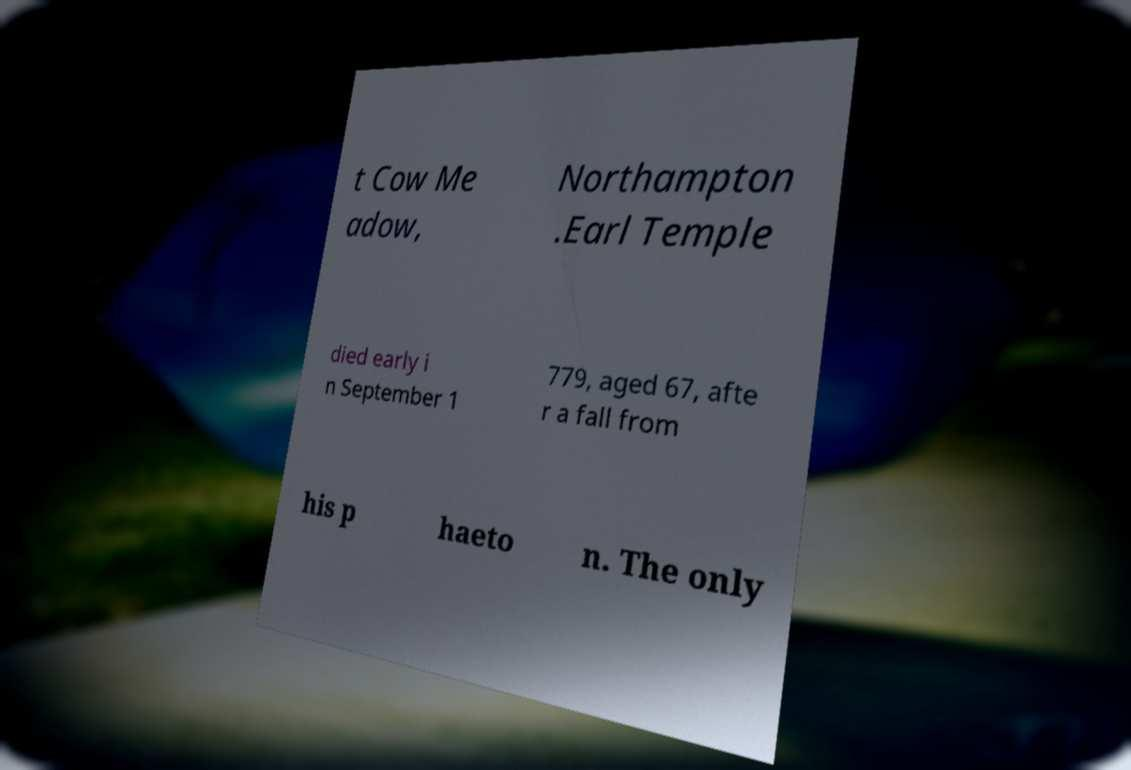Can you read and provide the text displayed in the image?This photo seems to have some interesting text. Can you extract and type it out for me? t Cow Me adow, Northampton .Earl Temple died early i n September 1 779, aged 67, afte r a fall from his p haeto n. The only 